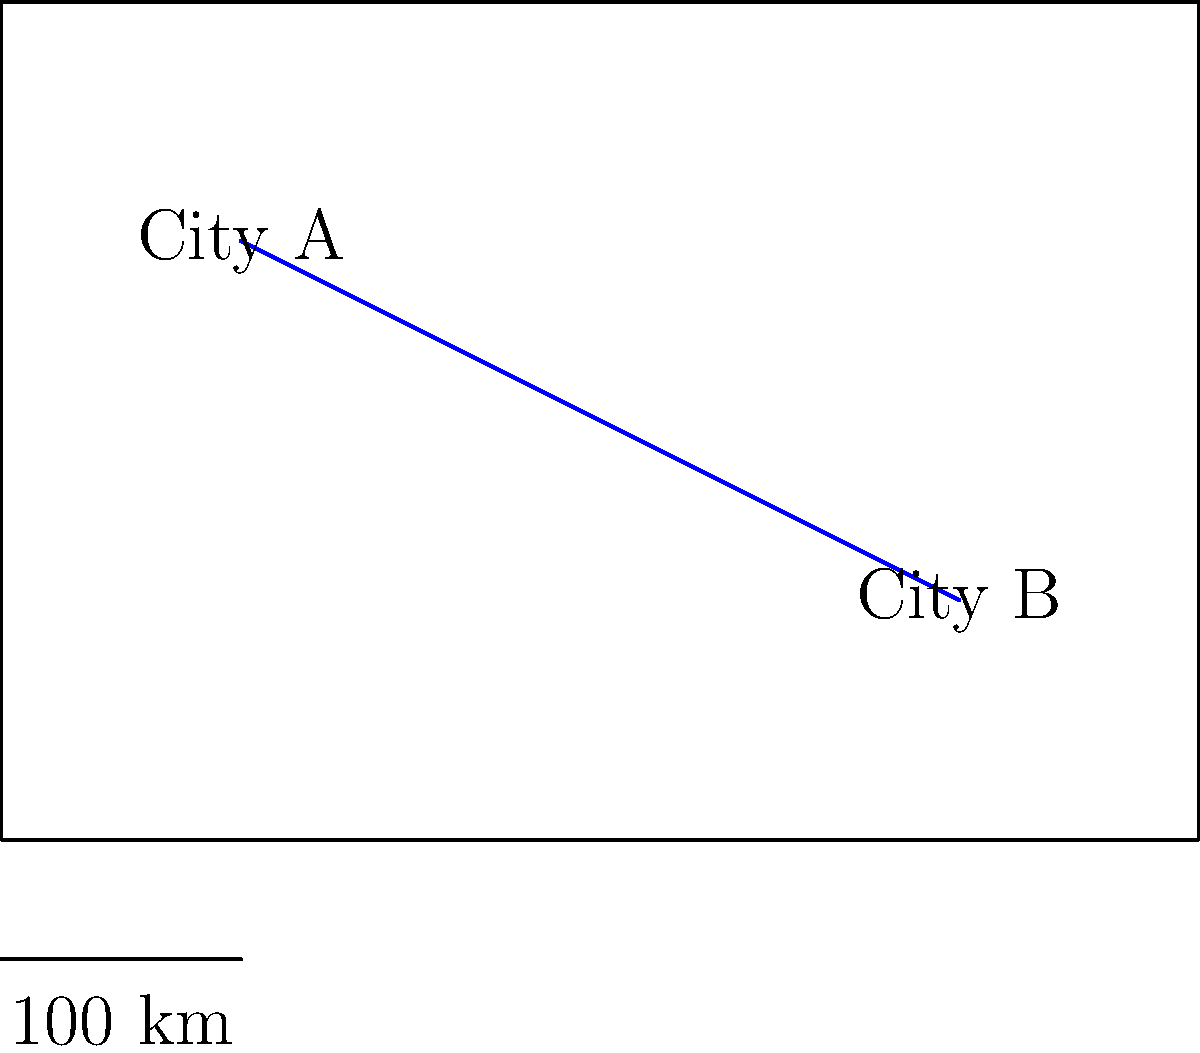As part of planning an educational field trip, you need to determine the distance between City A and City B on the map. Given that the scale shows 100 km for 2 cm on the map, and the measured distance between the cities is 7.5 cm, what is the actual distance between City A and City B? Let's approach this step-by-step:

1) First, we need to understand the scale:
   2 cm on the map = 100 km in reality

2) We can express this as a ratio:
   $$\frac{2 \text{ cm}}{100 \text{ km}} = \frac{1 \text{ cm}}{50 \text{ km}}$$

3) This means that 1 cm on the map represents 50 km in reality.

4) We're given that the measured distance between City A and City B on the map is 7.5 cm.

5) To find the actual distance, we need to multiply 7.5 by 50:
   $$7.5 \text{ cm} \times 50 \frac{\text{km}}{\text{cm}} = 375 \text{ km}$$

Therefore, the actual distance between City A and City B is 375 km.
Answer: 375 km 